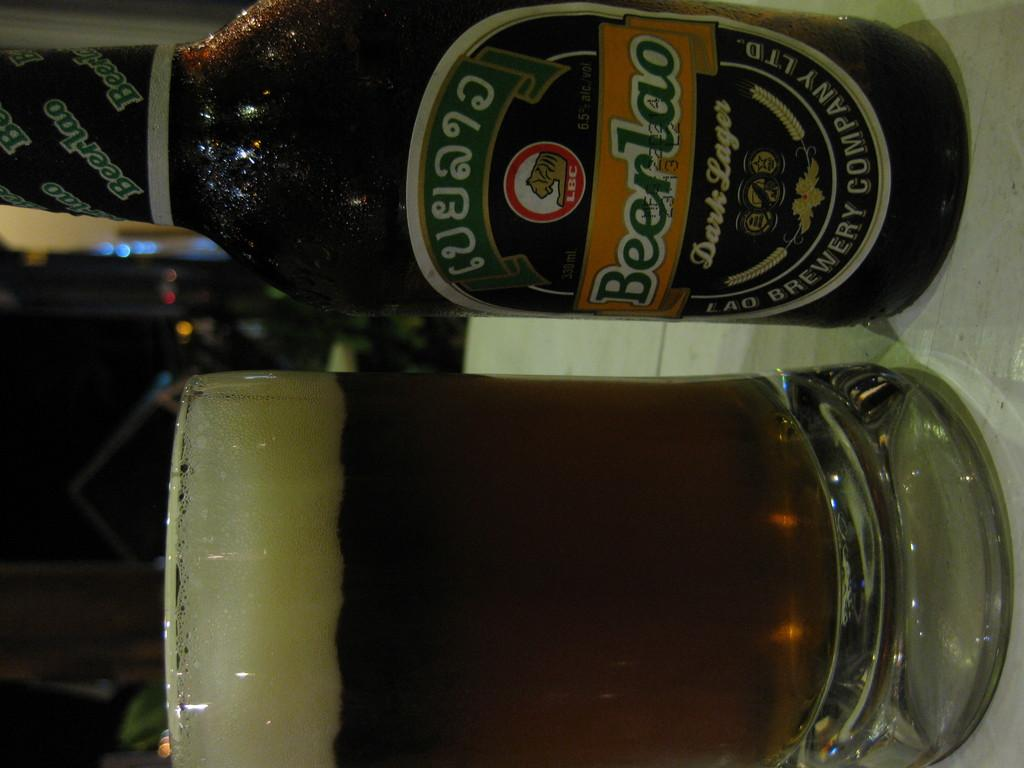<image>
Provide a brief description of the given image. A full glass next to a bottle of dark lager 